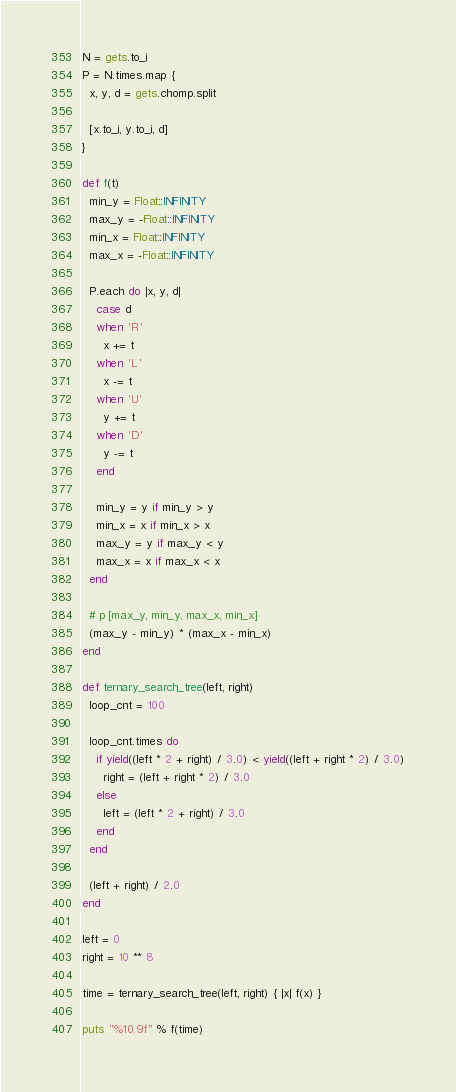<code> <loc_0><loc_0><loc_500><loc_500><_Ruby_>N = gets.to_i
P = N.times.map {
  x, y, d = gets.chomp.split

  [x.to_i, y.to_i, d]
}

def f(t)
  min_y = Float::INFINITY
  max_y = -Float::INFINITY
  min_x = Float::INFINITY
  max_x = -Float::INFINITY

  P.each do |x, y, d|
    case d
    when 'R'
      x += t
    when 'L'
      x -= t
    when 'U'
      y += t
    when 'D'
      y -= t
    end

    min_y = y if min_y > y
    min_x = x if min_x > x
    max_y = y if max_y < y
    max_x = x if max_x < x
  end

  # p [max_y, min_y, max_x, min_x]
  (max_y - min_y) * (max_x - min_x)
end

def ternary_search_tree(left, right)
  loop_cnt = 100

  loop_cnt.times do
    if yield((left * 2 + right) / 3.0) < yield((left + right * 2) / 3.0)
      right = (left + right * 2) / 3.0
    else
      left = (left * 2 + right) / 3.0
    end
  end

  (left + right) / 2.0
end

left = 0
right = 10 ** 8

time = ternary_search_tree(left, right) { |x| f(x) }

puts "%10.9f" % f(time)
</code> 